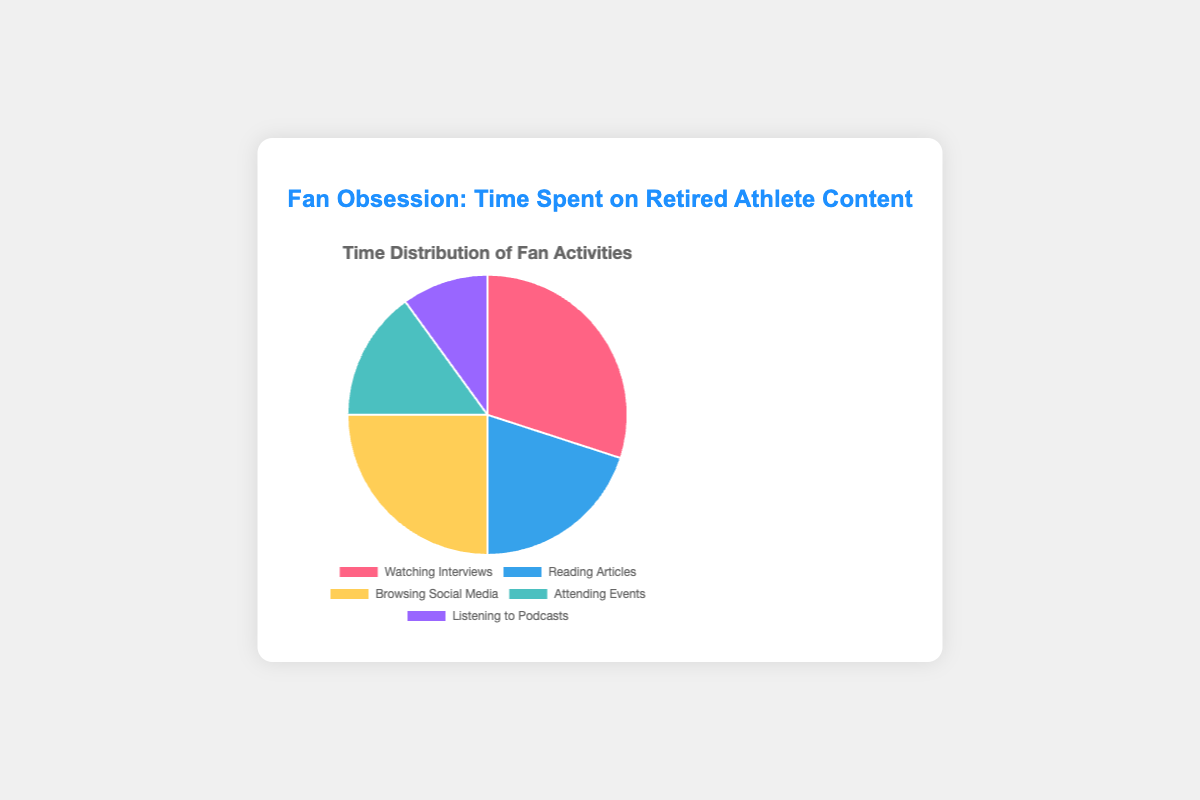Which category takes up the largest percentage of time spent on retired athlete content? The largest slice of the pie chart, identified by the size, represents the category with the highest percentage. Here, "Watching Interviews" has the largest percentage at 30%.
Answer: Watching Interviews How much more time is spent on "Watching Interviews" compared to "Listening to Podcasts"? To find the difference, subtract the percentage of "Listening to Podcasts" from "Watching Interviews" (30% - 10% = 20%).
Answer: 20% What is the combined percentage of time spent on "Reading Articles" and "Browsing Social Media"? Add the percentages of "Reading Articles" and "Browsing Social Media" (20% + 25% = 45%).
Answer: 45% Which category has the lowest percentage of time spent? The smallest slice of the pie chart represents the category with the lowest percentage. "Listening to Podcasts" takes up 10%, the lowest among all categories.
Answer: Listening to Podcasts Is more time spent on "Attending Events" or "Browsing Social Media"? Compare the percentages of "Attending Events" (15%) and "Browsing Social Media" (25%). Since 25% is greater than 15%, more time is spent on "Browsing Social Media".
Answer: Browsing Social Media By how much does the time spent on "Reading Articles" exceed the time spent on "Listening to Podcasts"? Subtract the percentage of "Listening to Podcasts" from "Reading Articles" (20% - 10% = 10%).
Answer: 10% What is the total percentage of time spent on activities other than "Watching Interviews"? Sum the percentages of all categories except "Watching Interviews" (20% + 25% + 15% + 10% = 70%).
Answer: 70% Which color represents the time spent on "Browsing Social Media"? Identify the legend or the color of the "Browsing Social Media" slice. In this chart, "Browsing Social Media" is represented by the color yellow.
Answer: Yellow How does the time spent on "Attending Events" compare to the time spent on "Reading Articles"? Compare the percentages of "Attending Events" (15%) and "Reading Articles" (20%). "Reading Articles" has a higher percentage, so more time is spent on it compared to "Attending Events".
Answer: Reading Articles What percentage of time is spent on activities involving active participation (Attending Events, Browsing Social Media)? Add the percentages for "Attending Events" and "Browsing Social Media" (15% + 25% = 40%).
Answer: 40% 